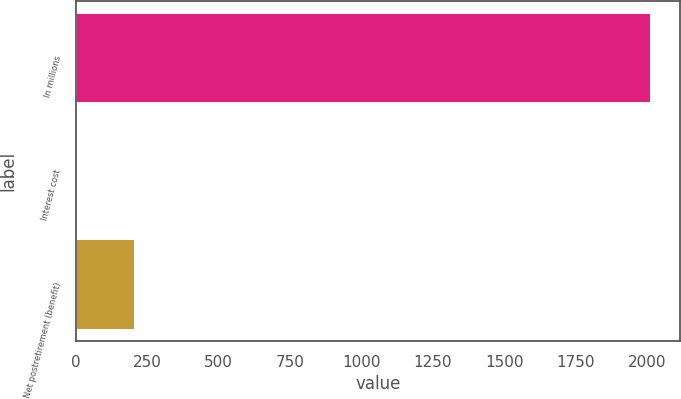Convert chart to OTSL. <chart><loc_0><loc_0><loc_500><loc_500><bar_chart><fcel>In millions<fcel>Interest cost<fcel>Net postretirement (benefit)<nl><fcel>2013<fcel>5<fcel>205.8<nl></chart> 